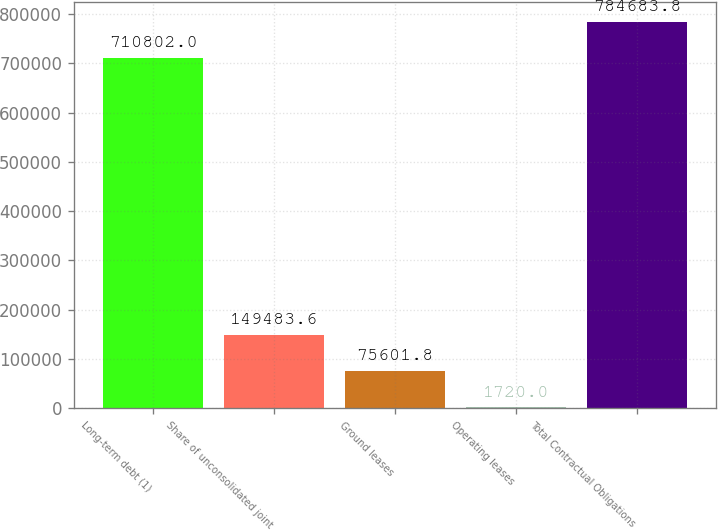Convert chart to OTSL. <chart><loc_0><loc_0><loc_500><loc_500><bar_chart><fcel>Long-term debt (1)<fcel>Share of unconsolidated joint<fcel>Ground leases<fcel>Operating leases<fcel>Total Contractual Obligations<nl><fcel>710802<fcel>149484<fcel>75601.8<fcel>1720<fcel>784684<nl></chart> 